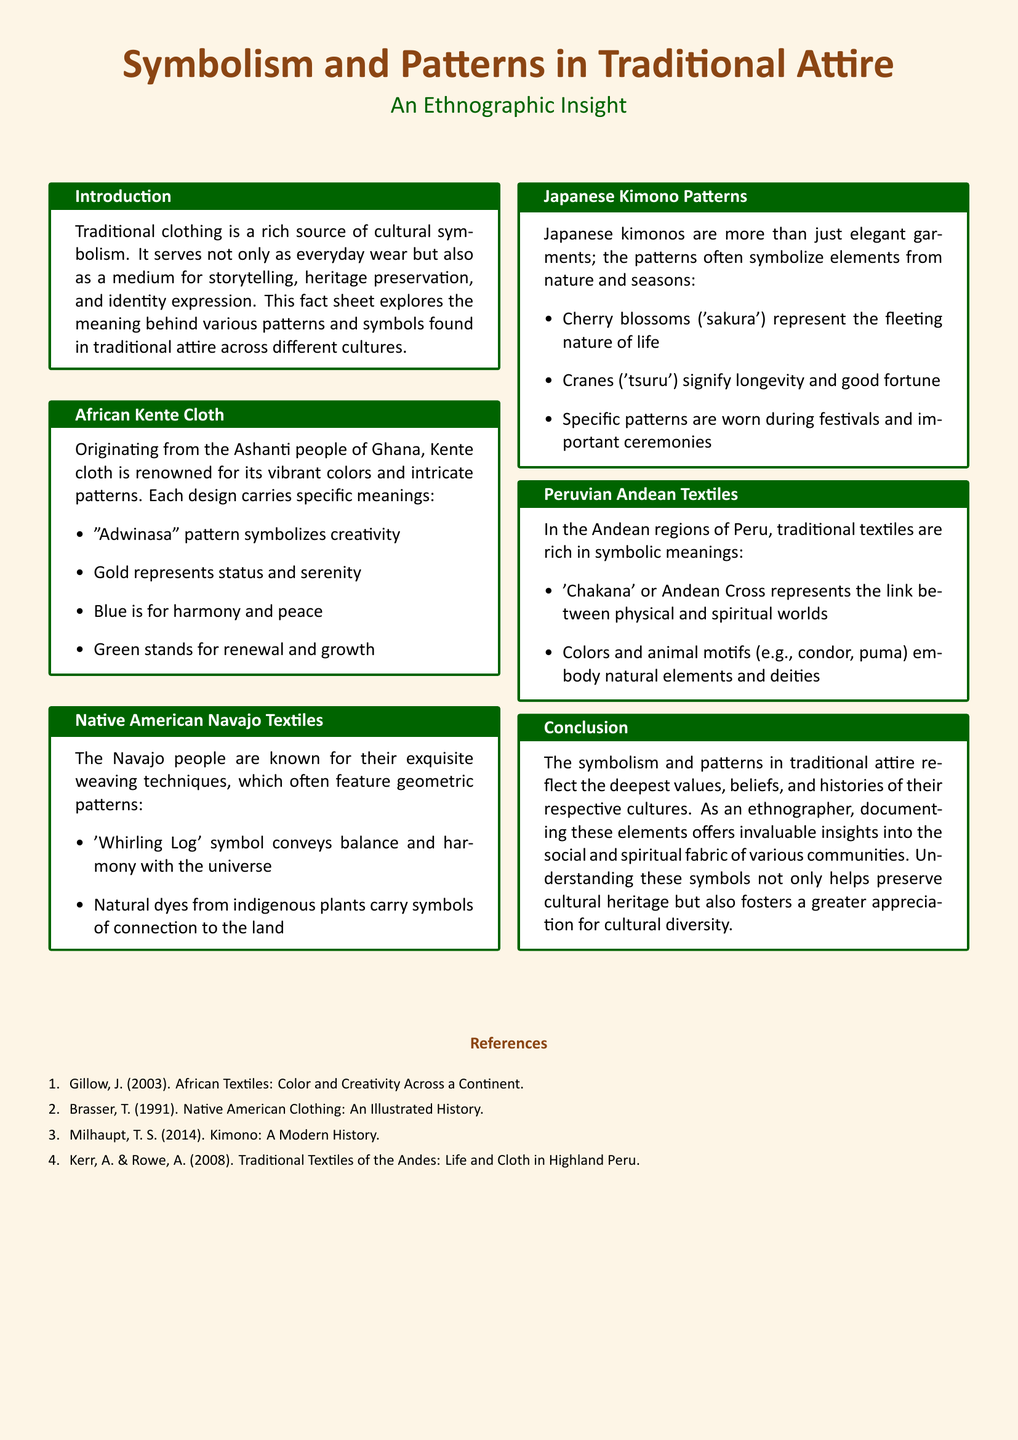What is the primary function of traditional clothing? Traditional clothing serves as a medium for storytelling, heritage preservation, and identity expression.
Answer: Heritage preservation What does the "Adwinasa" pattern symbolize in Kente cloth? The "Adwinasa" pattern symbolizes creativity according to the document.
Answer: Creativity Which pattern in Navajo textiles conveys balance and harmony? The 'Whirling Log' symbol is mentioned as conveying balance and harmony with the universe.
Answer: Whirling Log What do cherry blossoms represent in Japanese kimono patterns? Cherry blossoms ('sakura') represent the fleeting nature of life.
Answer: Fleeting nature of life What does the 'Chakana' cross symbolize in Peruvian textiles? The 'Chakana' or Andean Cross represents the link between physical and spiritual worlds.
Answer: Link between physical and spiritual worlds How do patterns in traditional attire reflect culture? The patterns reflect the deepest values, beliefs, and histories of their respective cultures.
Answer: Values and beliefs What two colors are associated with status and serenity in Kente cloth? Gold represents status and serenity in Kente cloth as described.
Answer: Gold How many cultural traditions are discussed in the document? The document discusses four cultural traditions in total.
Answer: Four Which animal motifs are mentioned in connection with Peruvian Andean textiles? The document mentions condor and puma as animal motifs in Andean textiles.
Answer: Condor, puma 